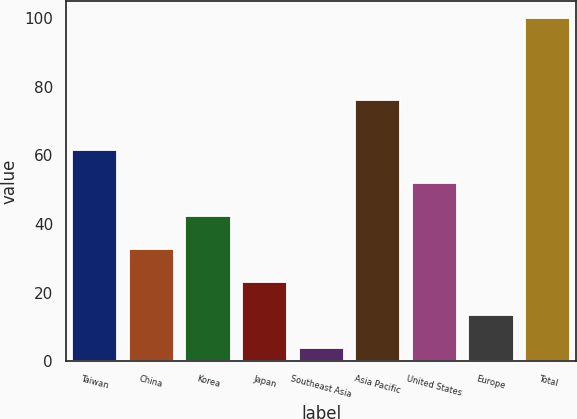Convert chart. <chart><loc_0><loc_0><loc_500><loc_500><bar_chart><fcel>Taiwan<fcel>China<fcel>Korea<fcel>Japan<fcel>Southeast Asia<fcel>Asia Pacific<fcel>United States<fcel>Europe<fcel>Total<nl><fcel>61.6<fcel>32.8<fcel>42.4<fcel>23.2<fcel>4<fcel>76<fcel>52<fcel>13.6<fcel>100<nl></chart> 